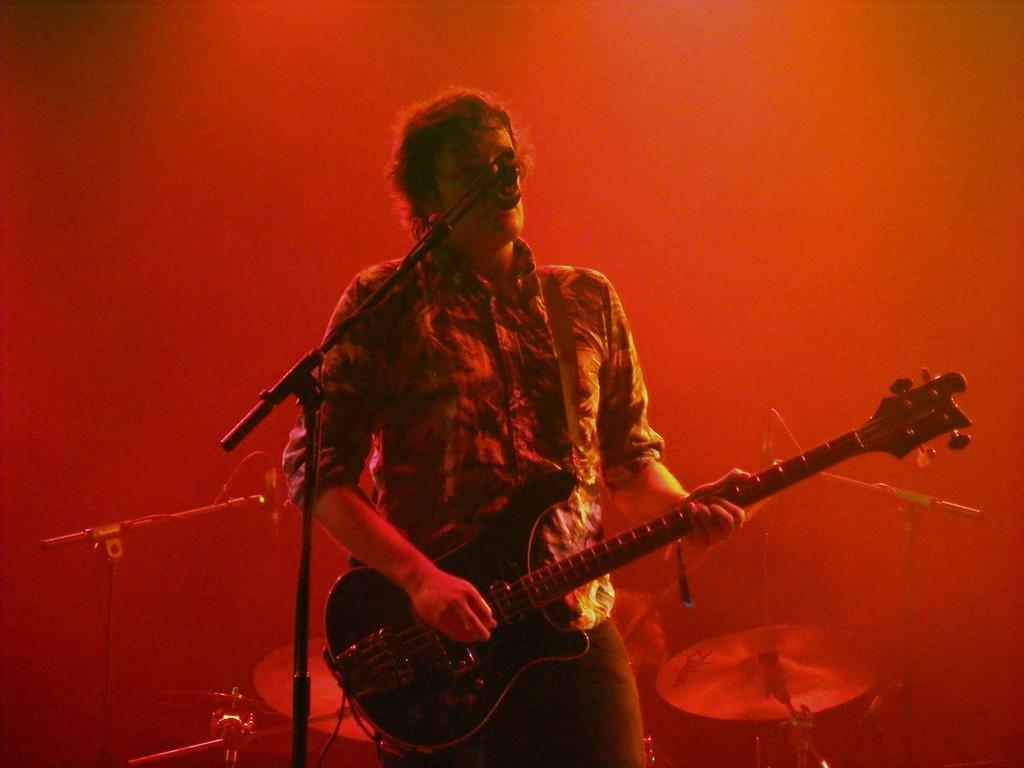Could you give a brief overview of what you see in this image? In this picture there is a man standing and playing guitar. In the foreground there is a microphone. At the back there are drums and there are microphones. 